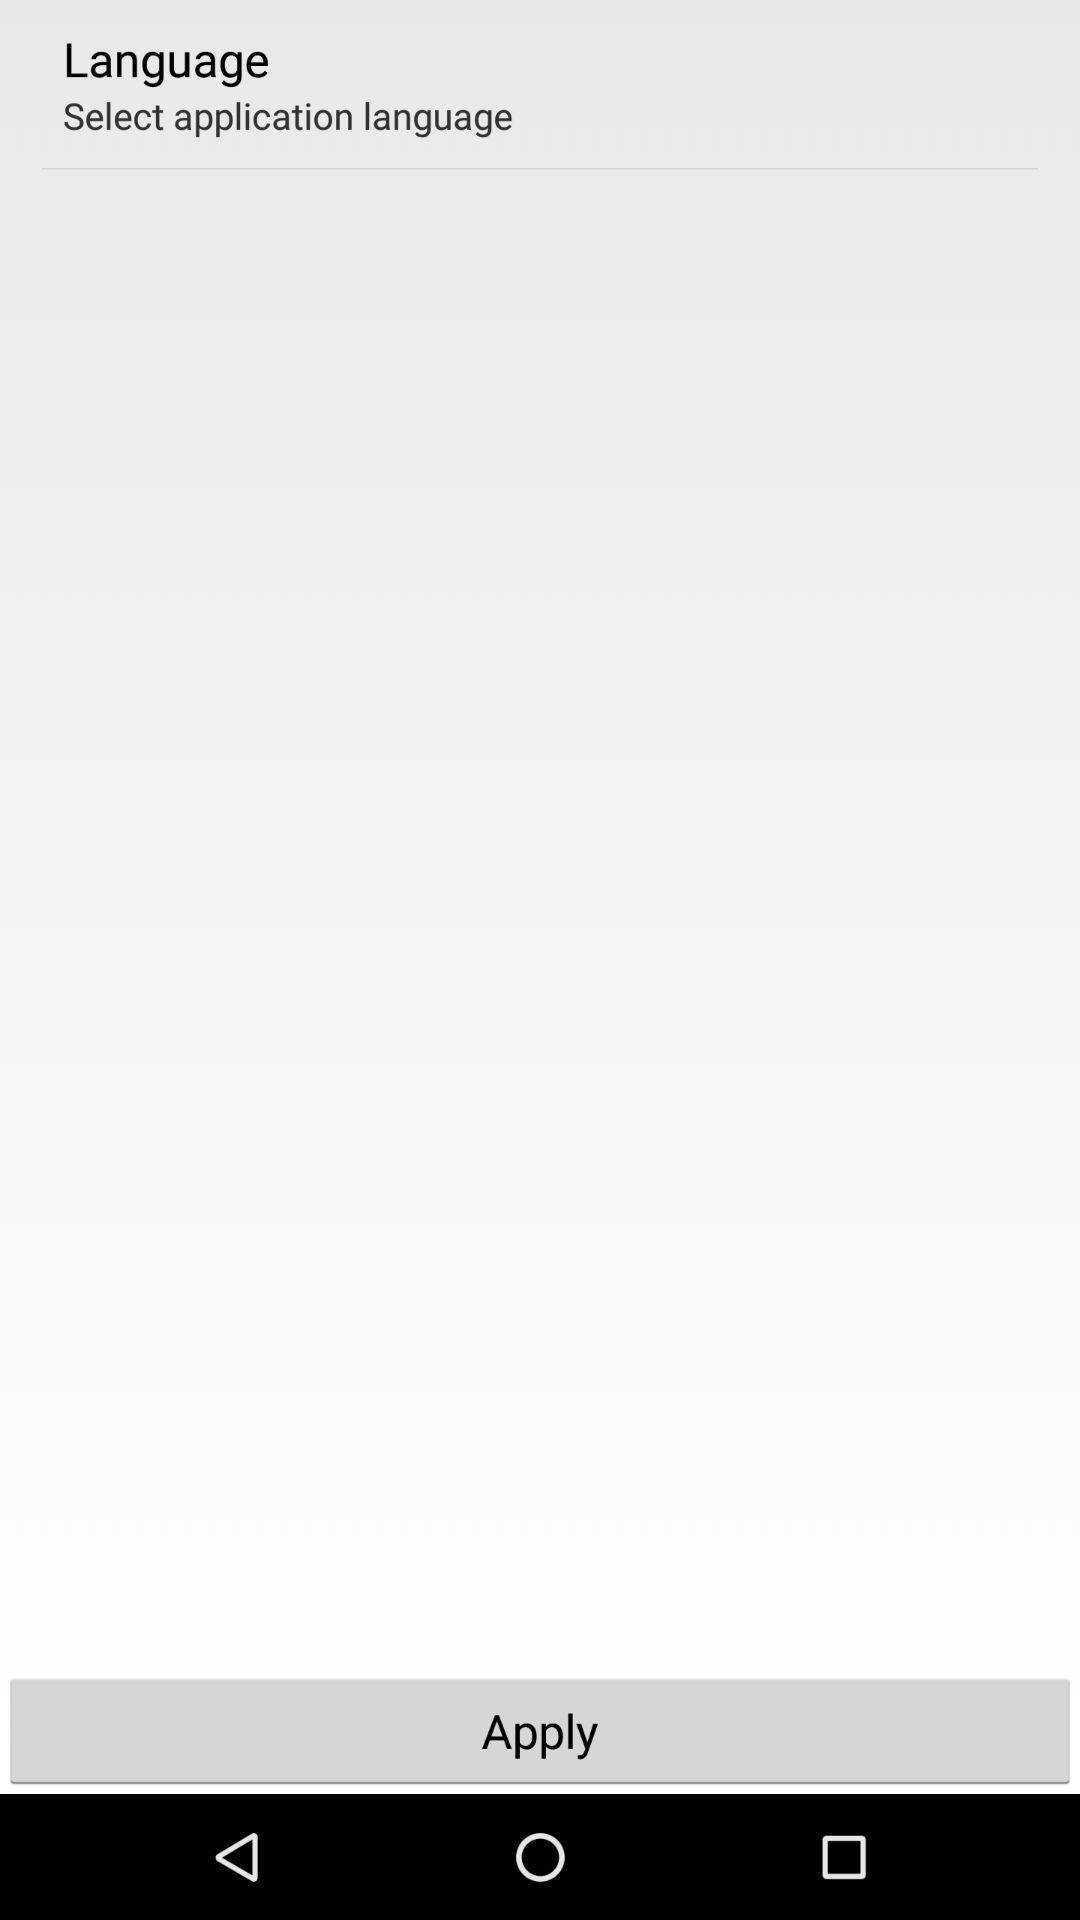What is the overall content of this screenshot? Screen page showing to select the language. 